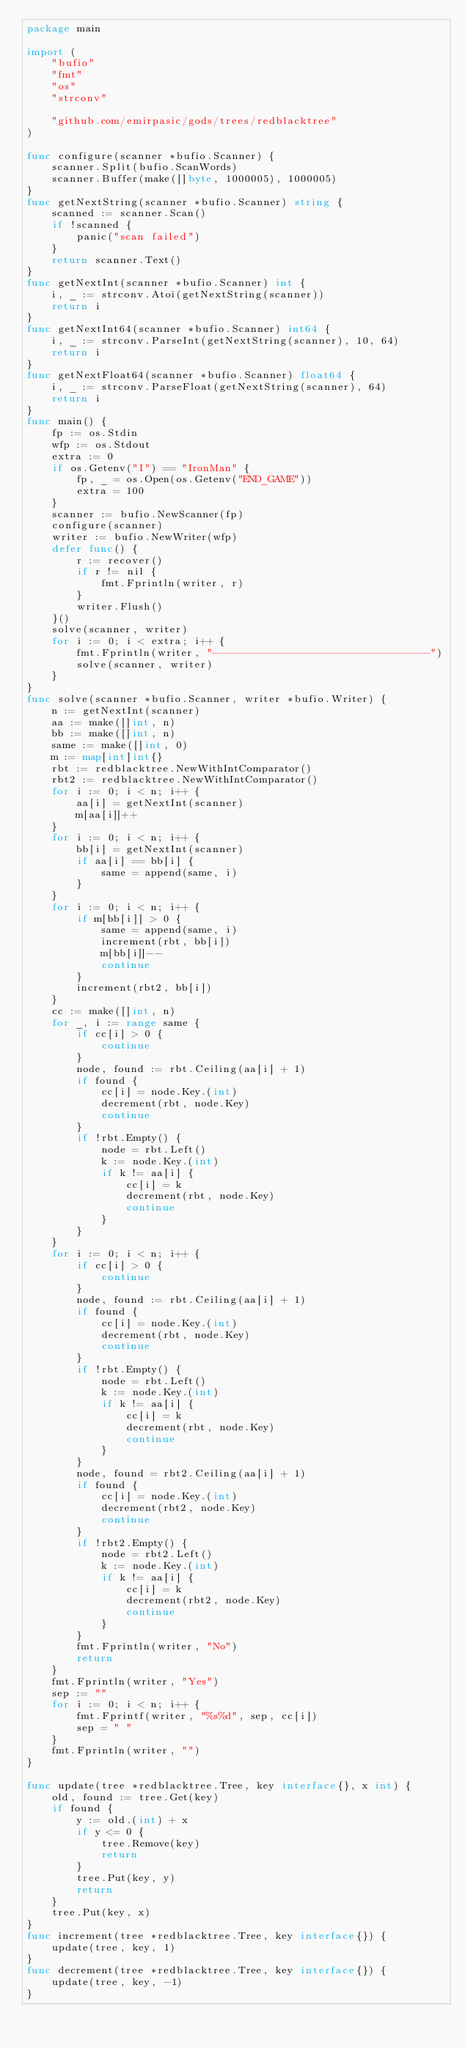Convert code to text. <code><loc_0><loc_0><loc_500><loc_500><_Go_>package main

import (
	"bufio"
	"fmt"
	"os"
	"strconv"

	"github.com/emirpasic/gods/trees/redblacktree"
)

func configure(scanner *bufio.Scanner) {
	scanner.Split(bufio.ScanWords)
	scanner.Buffer(make([]byte, 1000005), 1000005)
}
func getNextString(scanner *bufio.Scanner) string {
	scanned := scanner.Scan()
	if !scanned {
		panic("scan failed")
	}
	return scanner.Text()
}
func getNextInt(scanner *bufio.Scanner) int {
	i, _ := strconv.Atoi(getNextString(scanner))
	return i
}
func getNextInt64(scanner *bufio.Scanner) int64 {
	i, _ := strconv.ParseInt(getNextString(scanner), 10, 64)
	return i
}
func getNextFloat64(scanner *bufio.Scanner) float64 {
	i, _ := strconv.ParseFloat(getNextString(scanner), 64)
	return i
}
func main() {
	fp := os.Stdin
	wfp := os.Stdout
	extra := 0
	if os.Getenv("I") == "IronMan" {
		fp, _ = os.Open(os.Getenv("END_GAME"))
		extra = 100
	}
	scanner := bufio.NewScanner(fp)
	configure(scanner)
	writer := bufio.NewWriter(wfp)
	defer func() {
		r := recover()
		if r != nil {
			fmt.Fprintln(writer, r)
		}
		writer.Flush()
	}()
	solve(scanner, writer)
	for i := 0; i < extra; i++ {
		fmt.Fprintln(writer, "-----------------------------------")
		solve(scanner, writer)
	}
}
func solve(scanner *bufio.Scanner, writer *bufio.Writer) {
	n := getNextInt(scanner)
	aa := make([]int, n)
	bb := make([]int, n)
	same := make([]int, 0)
	m := map[int]int{}
	rbt := redblacktree.NewWithIntComparator()
	rbt2 := redblacktree.NewWithIntComparator()
	for i := 0; i < n; i++ {
		aa[i] = getNextInt(scanner)
		m[aa[i]]++
	}
	for i := 0; i < n; i++ {
		bb[i] = getNextInt(scanner)
		if aa[i] == bb[i] {
			same = append(same, i)
		}
	}
	for i := 0; i < n; i++ {
		if m[bb[i]] > 0 {
			same = append(same, i)
			increment(rbt, bb[i])
			m[bb[i]]--
			continue
		}
		increment(rbt2, bb[i])
	}
	cc := make([]int, n)
	for _, i := range same {
		if cc[i] > 0 {
			continue
		}
		node, found := rbt.Ceiling(aa[i] + 1)
		if found {
			cc[i] = node.Key.(int)
			decrement(rbt, node.Key)
			continue
		}
		if !rbt.Empty() {
			node = rbt.Left()
			k := node.Key.(int)
			if k != aa[i] {
				cc[i] = k
				decrement(rbt, node.Key)
				continue
			}
		}
	}
	for i := 0; i < n; i++ {
		if cc[i] > 0 {
			continue
		}
		node, found := rbt.Ceiling(aa[i] + 1)
		if found {
			cc[i] = node.Key.(int)
			decrement(rbt, node.Key)
			continue
		}
		if !rbt.Empty() {
			node = rbt.Left()
			k := node.Key.(int)
			if k != aa[i] {
				cc[i] = k
				decrement(rbt, node.Key)
				continue
			}
		}
		node, found = rbt2.Ceiling(aa[i] + 1)
		if found {
			cc[i] = node.Key.(int)
			decrement(rbt2, node.Key)
			continue
		}
		if !rbt2.Empty() {
			node = rbt2.Left()
			k := node.Key.(int)
			if k != aa[i] {
				cc[i] = k
				decrement(rbt2, node.Key)
				continue
			}
		}
		fmt.Fprintln(writer, "No")
		return
	}
	fmt.Fprintln(writer, "Yes")
	sep := ""
	for i := 0; i < n; i++ {
		fmt.Fprintf(writer, "%s%d", sep, cc[i])
		sep = " "
	}
	fmt.Fprintln(writer, "")
}

func update(tree *redblacktree.Tree, key interface{}, x int) {
	old, found := tree.Get(key)
	if found {
		y := old.(int) + x
		if y <= 0 {
			tree.Remove(key)
			return
		}
		tree.Put(key, y)
		return
	}
	tree.Put(key, x)
}
func increment(tree *redblacktree.Tree, key interface{}) {
	update(tree, key, 1)
}
func decrement(tree *redblacktree.Tree, key interface{}) {
	update(tree, key, -1)
}
</code> 